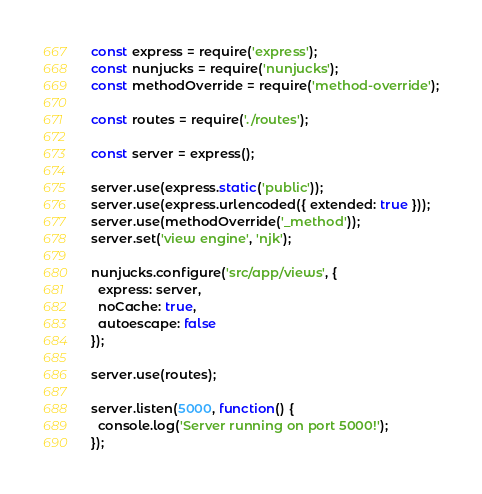Convert code to text. <code><loc_0><loc_0><loc_500><loc_500><_JavaScript_>const express = require('express');
const nunjucks = require('nunjucks');
const methodOverride = require('method-override');

const routes = require('./routes');

const server = express();

server.use(express.static('public'));
server.use(express.urlencoded({ extended: true }));
server.use(methodOverride('_method'));
server.set('view engine', 'njk');

nunjucks.configure('src/app/views', {
  express: server,
  noCache: true,
  autoescape: false
});

server.use(routes);

server.listen(5000, function() {
  console.log('Server running on port 5000!');
});
</code> 